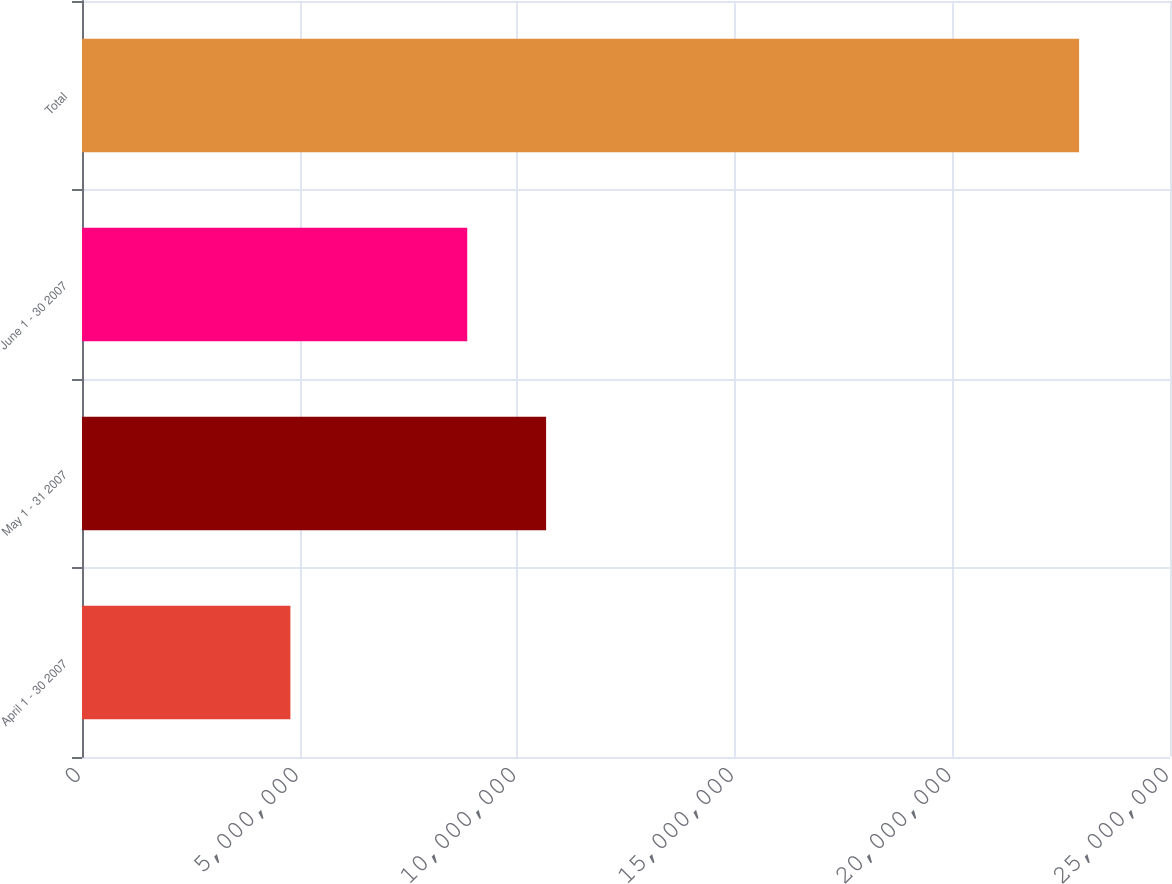Convert chart. <chart><loc_0><loc_0><loc_500><loc_500><bar_chart><fcel>April 1 - 30 2007<fcel>May 1 - 31 2007<fcel>June 1 - 30 2007<fcel>Total<nl><fcel>4.78852e+06<fcel>1.06641e+07<fcel>8.85181e+06<fcel>2.29114e+07<nl></chart> 